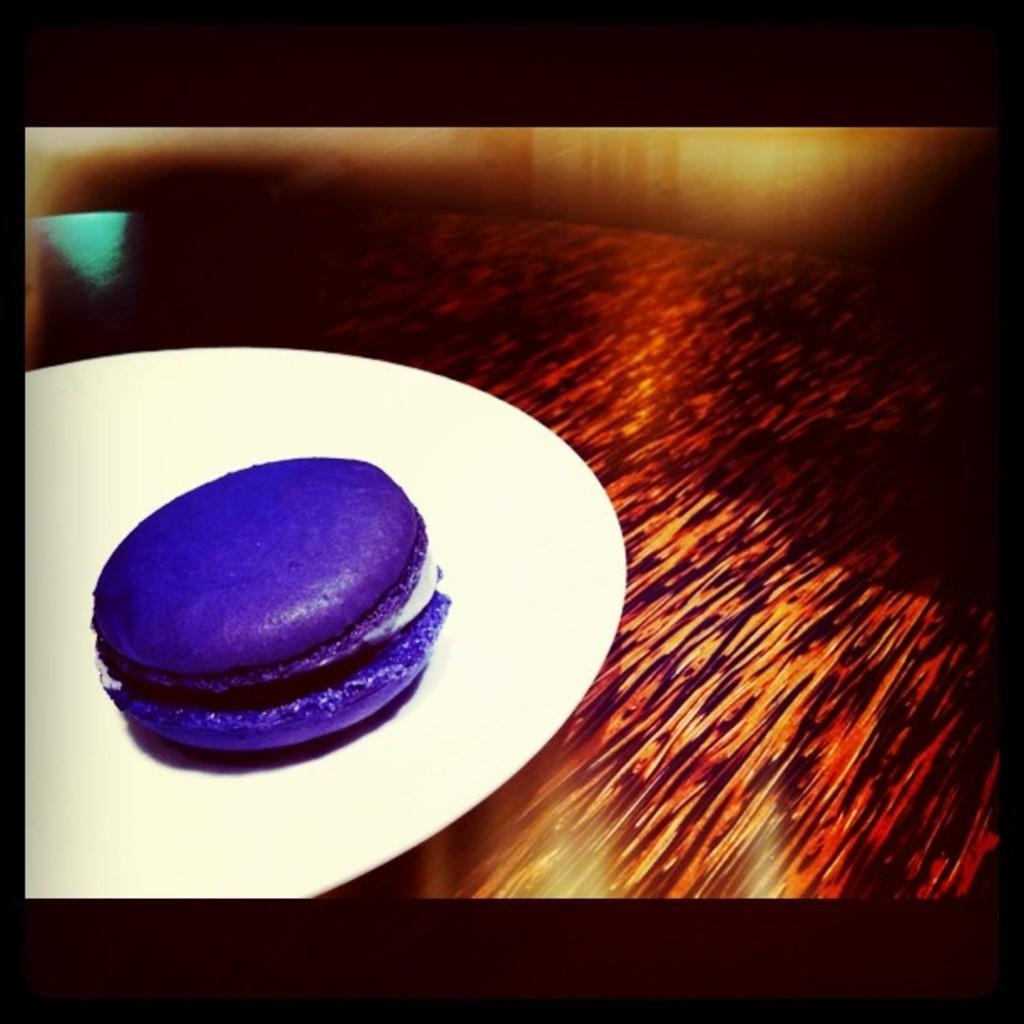Please provide a concise description of this image. This is an edited image. In which there is borders. There is a table on table there is a plate. In plate there is a food item. 